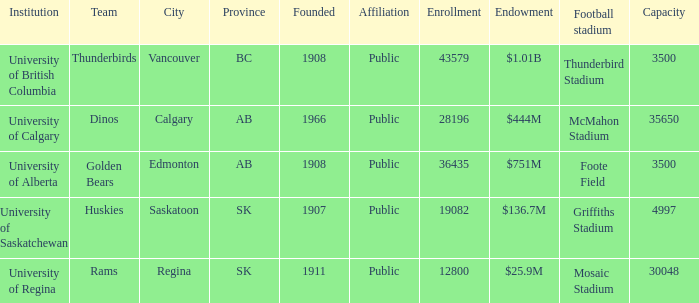What year marks the establishment of the dinos team? 1966.0. 